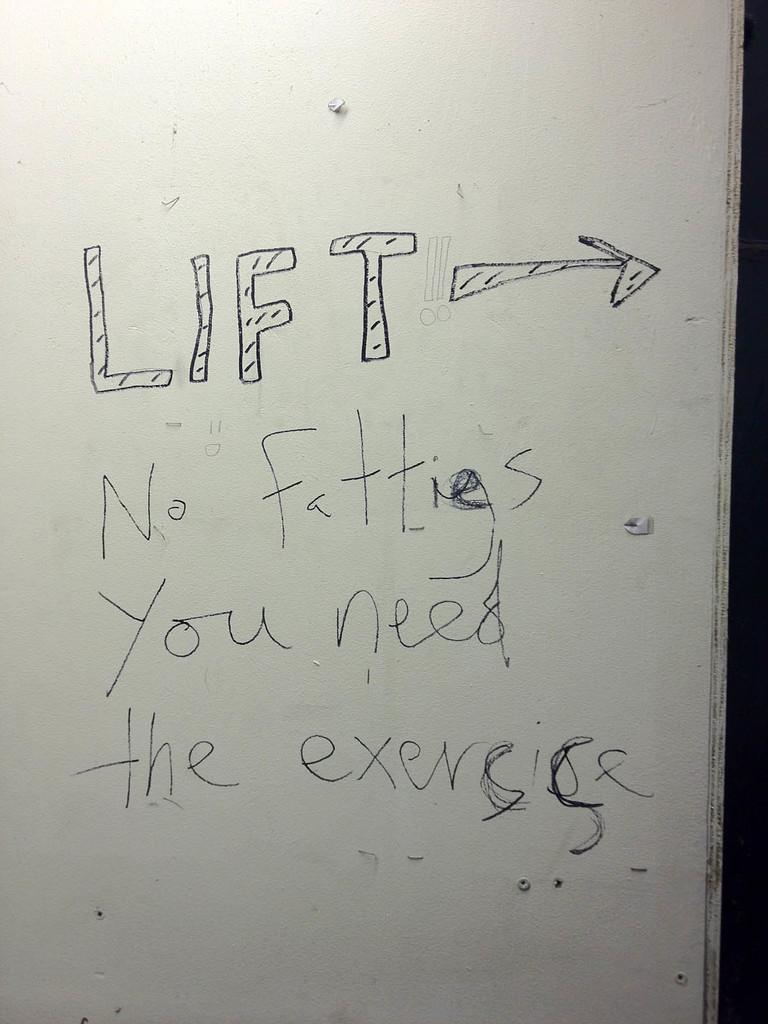What does the sign say?
Your response must be concise. Lift no fatties you need the exercise. Is that sign written well?
Your answer should be very brief. No. 